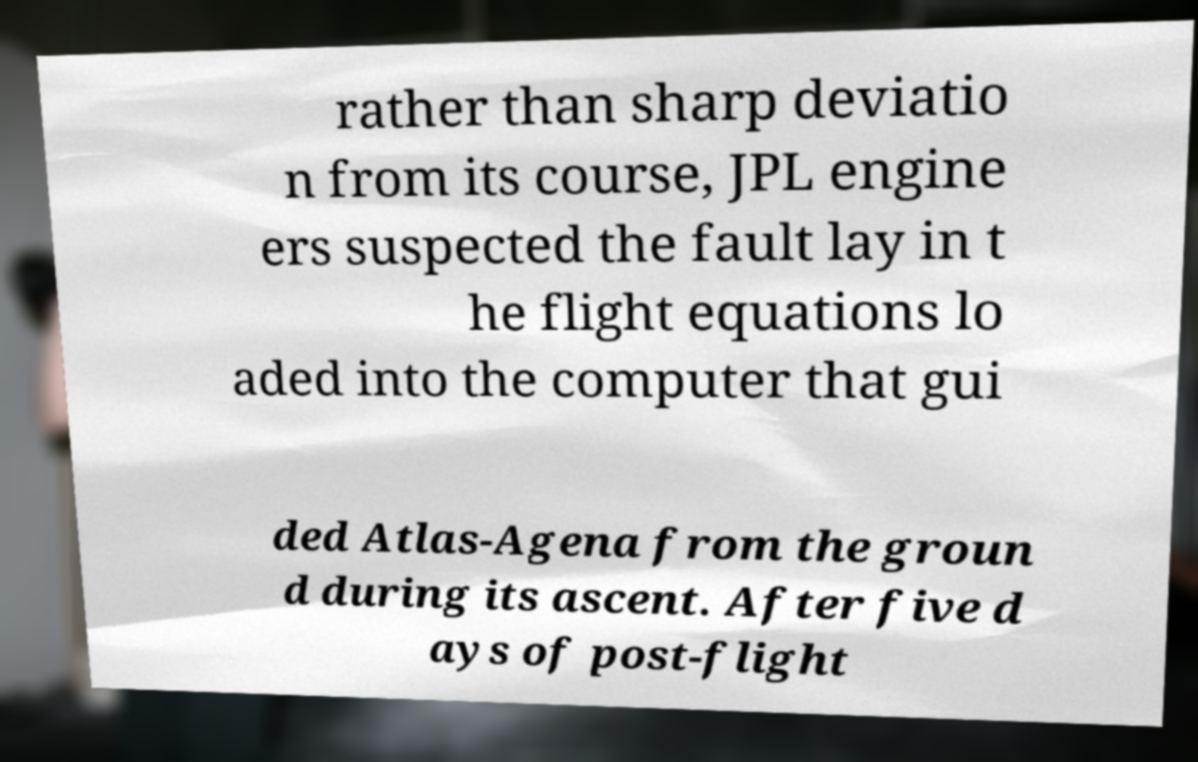I need the written content from this picture converted into text. Can you do that? rather than sharp deviatio n from its course, JPL engine ers suspected the fault lay in t he flight equations lo aded into the computer that gui ded Atlas-Agena from the groun d during its ascent. After five d ays of post-flight 